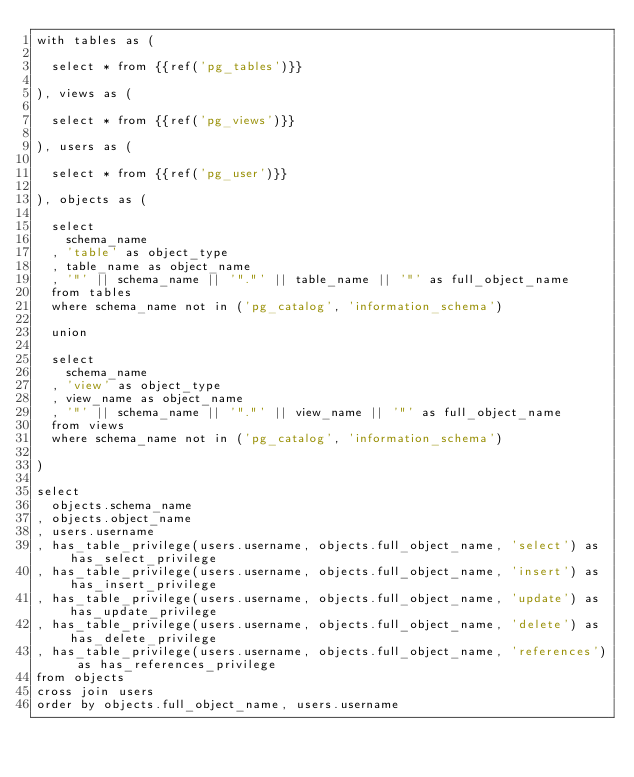Convert code to text. <code><loc_0><loc_0><loc_500><loc_500><_SQL_>with tables as (

  select * from {{ref('pg_tables')}}

), views as (

  select * from {{ref('pg_views')}}

), users as (

  select * from {{ref('pg_user')}}

), objects as (
  
  select
    schema_name
  , 'table' as object_type
  , table_name as object_name
  , '"' || schema_name || '"."' || table_name || '"' as full_object_name
  from tables
  where schema_name not in ('pg_catalog', 'information_schema')
  
  union
  
  select
    schema_name
  , 'view' as object_type
  , view_name as object_name
  , '"' || schema_name || '"."' || view_name || '"' as full_object_name
  from views
  where schema_name not in ('pg_catalog', 'information_schema')
  
)

select 
  objects.schema_name
, objects.object_name
, users.username
, has_table_privilege(users.username, objects.full_object_name, 'select') as has_select_privilege
, has_table_privilege(users.username, objects.full_object_name, 'insert') as has_insert_privilege
, has_table_privilege(users.username, objects.full_object_name, 'update') as has_update_privilege
, has_table_privilege(users.username, objects.full_object_name, 'delete') as has_delete_privilege
, has_table_privilege(users.username, objects.full_object_name, 'references') as has_references_privilege
from objects
cross join users
order by objects.full_object_name, users.username
</code> 